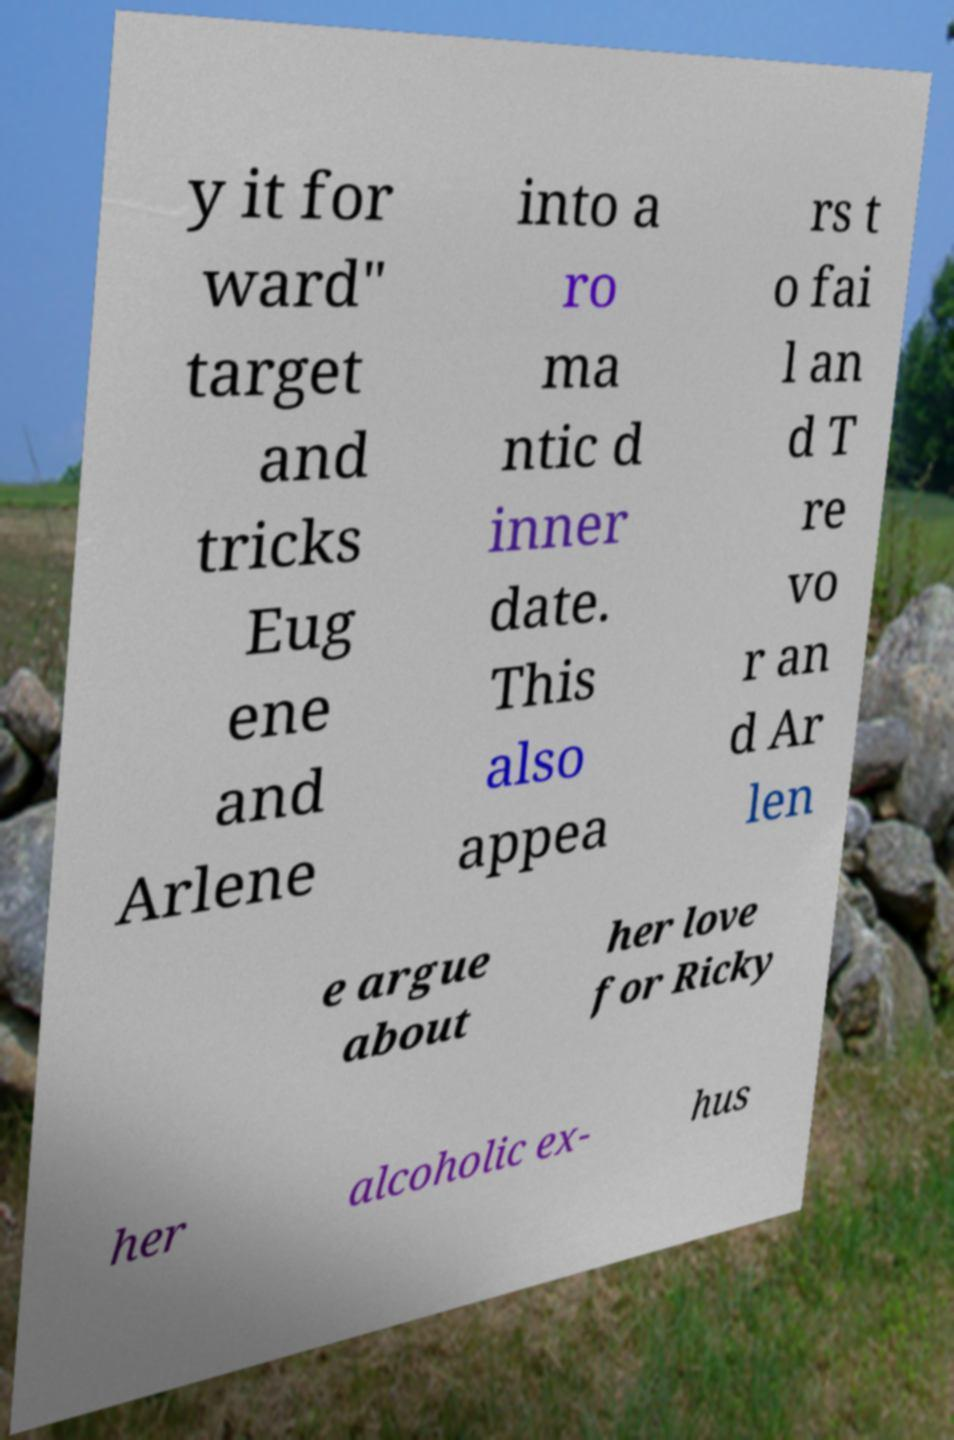I need the written content from this picture converted into text. Can you do that? y it for ward" target and tricks Eug ene and Arlene into a ro ma ntic d inner date. This also appea rs t o fai l an d T re vo r an d Ar len e argue about her love for Ricky her alcoholic ex- hus 